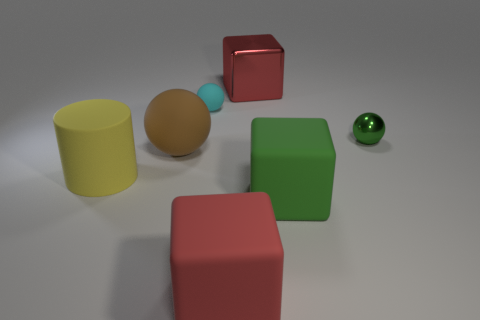The matte cube that is the same color as the big metal block is what size?
Ensure brevity in your answer.  Large. There is a matte thing that is the same color as the tiny metallic ball; what shape is it?
Provide a short and direct response. Cube. There is a big object that is the same shape as the small shiny object; what color is it?
Offer a terse response. Brown. Are the large red object behind the large cylinder and the big yellow cylinder made of the same material?
Provide a succinct answer. No. How many big objects are yellow rubber cylinders or purple spheres?
Your answer should be very brief. 1. What is the size of the red rubber cube?
Offer a very short reply. Large. Does the rubber cylinder have the same size as the metal thing to the left of the green shiny ball?
Make the answer very short. Yes. What number of cyan objects are cubes or large cylinders?
Keep it short and to the point. 0. What number of tiny things are there?
Offer a terse response. 2. There is a rubber block left of the large green thing; how big is it?
Keep it short and to the point. Large. 